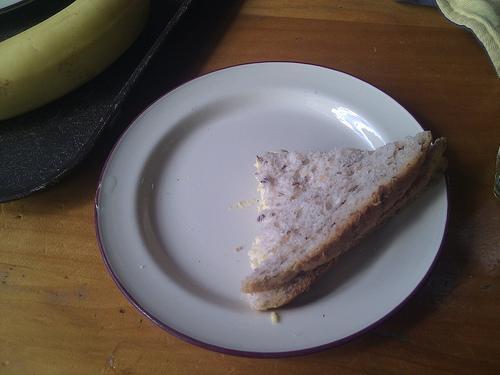How many plates are here?
Give a very brief answer. 1. 